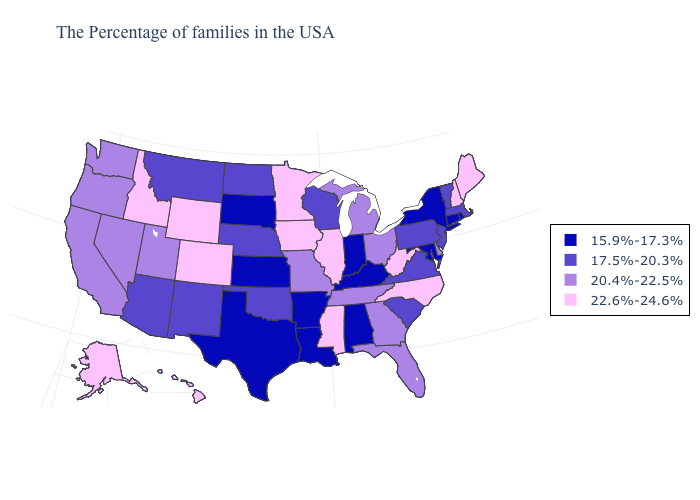What is the value of Florida?
Give a very brief answer. 20.4%-22.5%. What is the value of Utah?
Quick response, please. 20.4%-22.5%. Name the states that have a value in the range 22.6%-24.6%?
Quick response, please. Maine, New Hampshire, North Carolina, West Virginia, Illinois, Mississippi, Minnesota, Iowa, Wyoming, Colorado, Idaho, Alaska, Hawaii. What is the highest value in the South ?
Be succinct. 22.6%-24.6%. What is the value of Louisiana?
Keep it brief. 15.9%-17.3%. Does Oklahoma have the same value as Pennsylvania?
Give a very brief answer. Yes. Which states hav the highest value in the West?
Give a very brief answer. Wyoming, Colorado, Idaho, Alaska, Hawaii. Does Alabama have the lowest value in the South?
Give a very brief answer. Yes. Among the states that border Maryland , does West Virginia have the highest value?
Be succinct. Yes. Name the states that have a value in the range 15.9%-17.3%?
Answer briefly. Rhode Island, Connecticut, New York, Maryland, Kentucky, Indiana, Alabama, Louisiana, Arkansas, Kansas, Texas, South Dakota. Which states have the lowest value in the MidWest?
Quick response, please. Indiana, Kansas, South Dakota. What is the lowest value in the MidWest?
Concise answer only. 15.9%-17.3%. Does Hawaii have a lower value than Illinois?
Give a very brief answer. No. Does Michigan have the same value as Ohio?
Concise answer only. Yes. What is the highest value in the USA?
Short answer required. 22.6%-24.6%. 